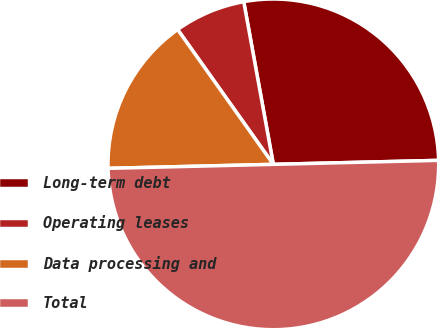Convert chart. <chart><loc_0><loc_0><loc_500><loc_500><pie_chart><fcel>Long-term debt<fcel>Operating leases<fcel>Data processing and<fcel>Total<nl><fcel>27.48%<fcel>6.96%<fcel>15.56%<fcel>50.0%<nl></chart> 